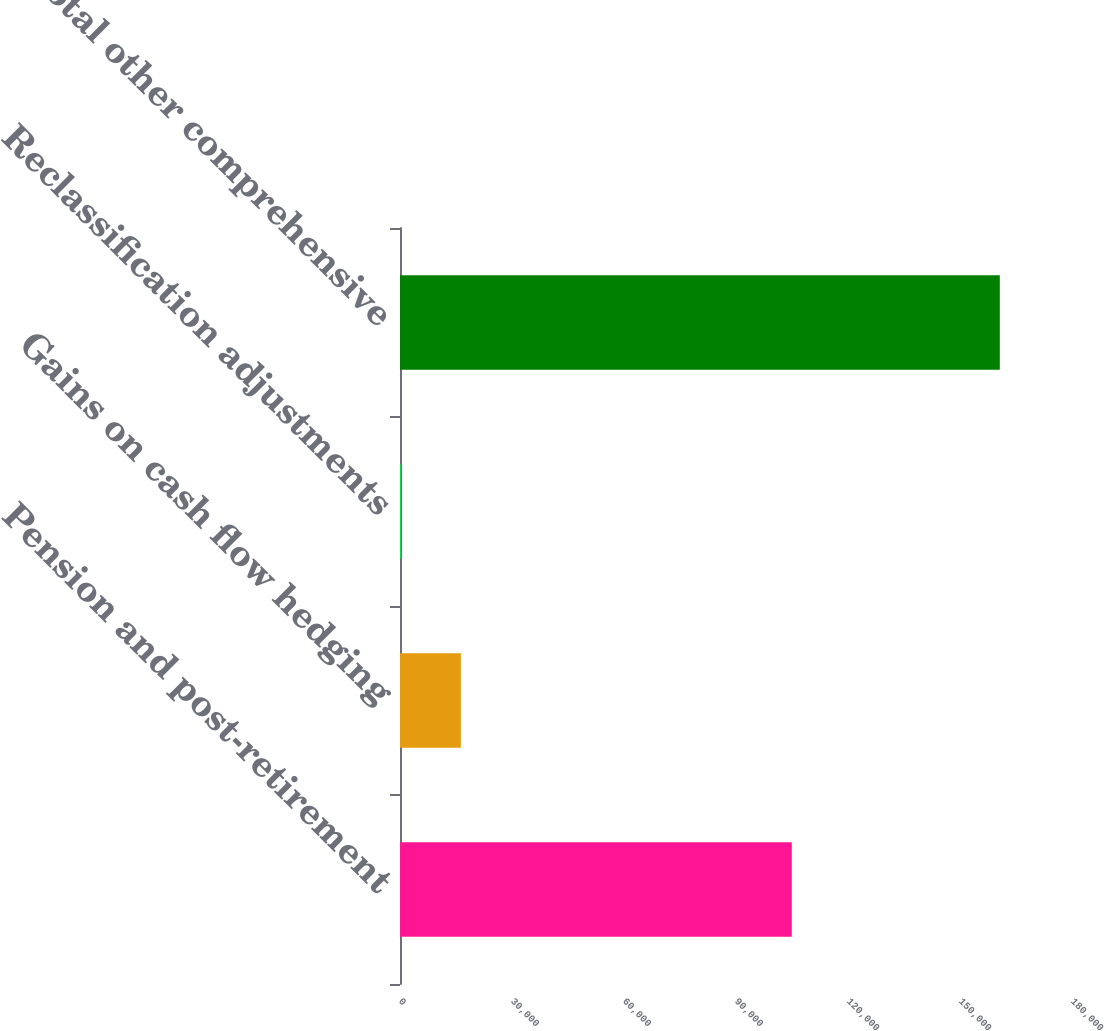Convert chart. <chart><loc_0><loc_0><loc_500><loc_500><bar_chart><fcel>Pension and post-retirement<fcel>Gains on cash flow hedging<fcel>Reclassification adjustments<fcel>Total other comprehensive<nl><fcel>104942<fcel>16293<fcel>252<fcel>160662<nl></chart> 